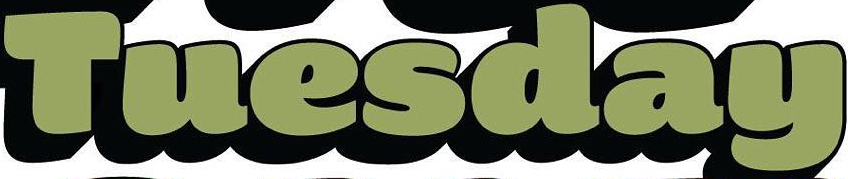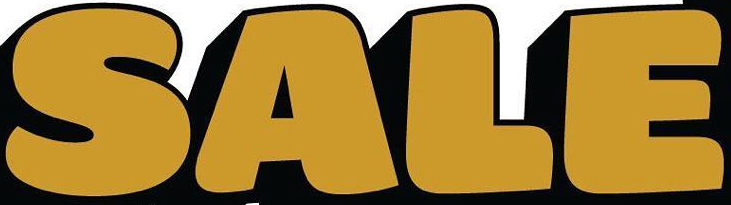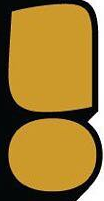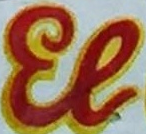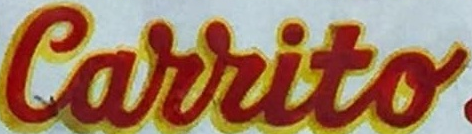What words are shown in these images in order, separated by a semicolon? Tuesday; SALE; !; El; Carrito 